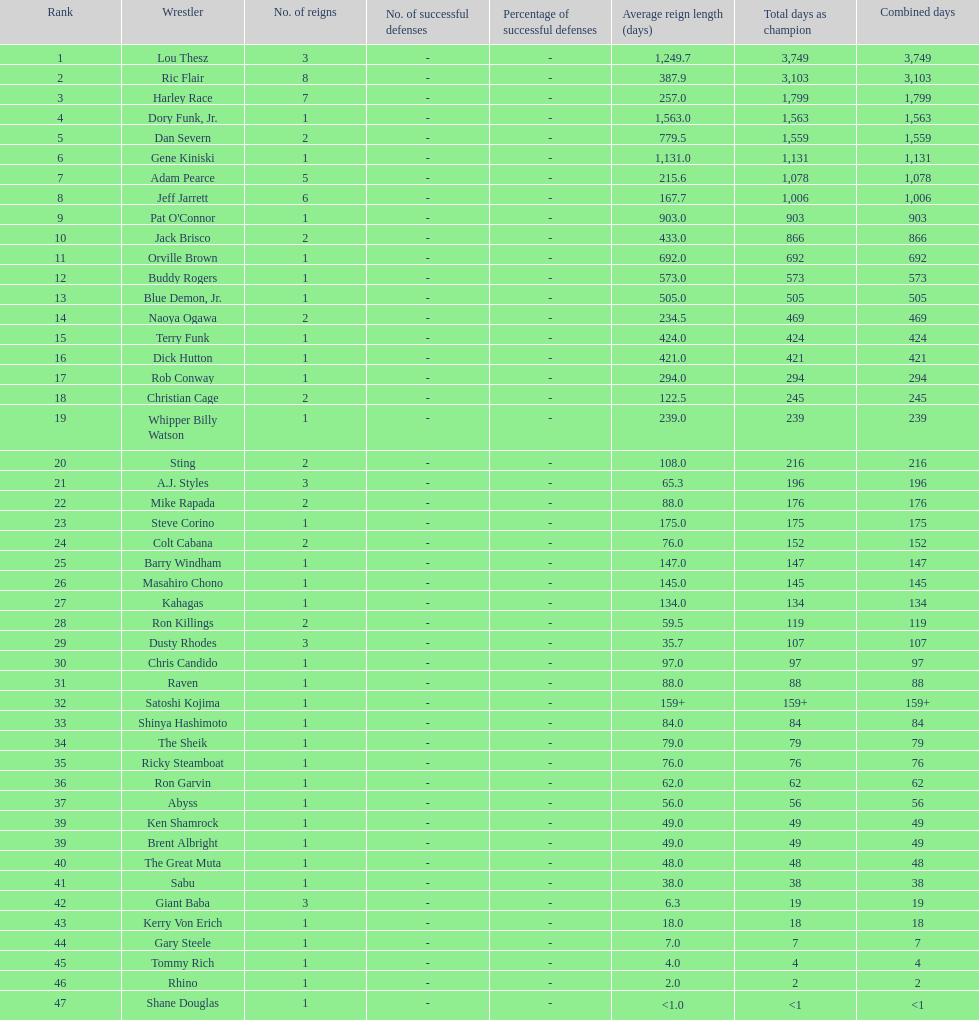Which professional wrestler has had the most number of reigns as nwa world heavyweight champion? Ric Flair. 